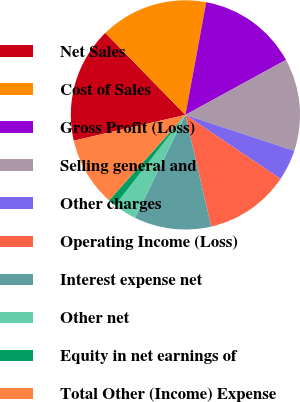<chart> <loc_0><loc_0><loc_500><loc_500><pie_chart><fcel>Net Sales<fcel>Cost of Sales<fcel>Gross Profit (Loss)<fcel>Selling general and<fcel>Other charges<fcel>Operating Income (Loss)<fcel>Interest expense net<fcel>Other net<fcel>Equity in net earnings of<fcel>Total Other (Income) Expense<nl><fcel>16.3%<fcel>15.22%<fcel>14.13%<fcel>13.04%<fcel>4.35%<fcel>11.96%<fcel>10.87%<fcel>3.26%<fcel>1.09%<fcel>9.78%<nl></chart> 